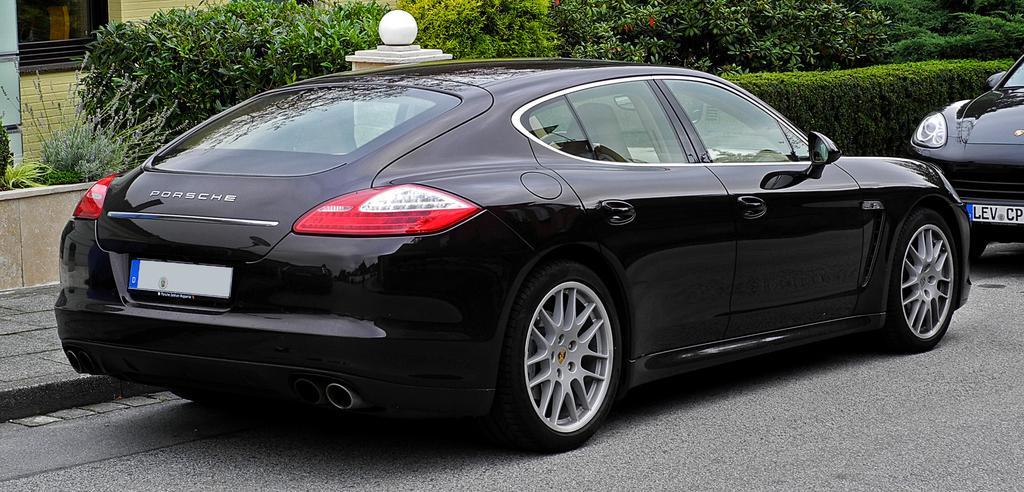Describe this image in one or two sentences. In this image we can see some cars parked on the road. On the backside we can see a footpath, a street lamp, a group of plants and a wall. 